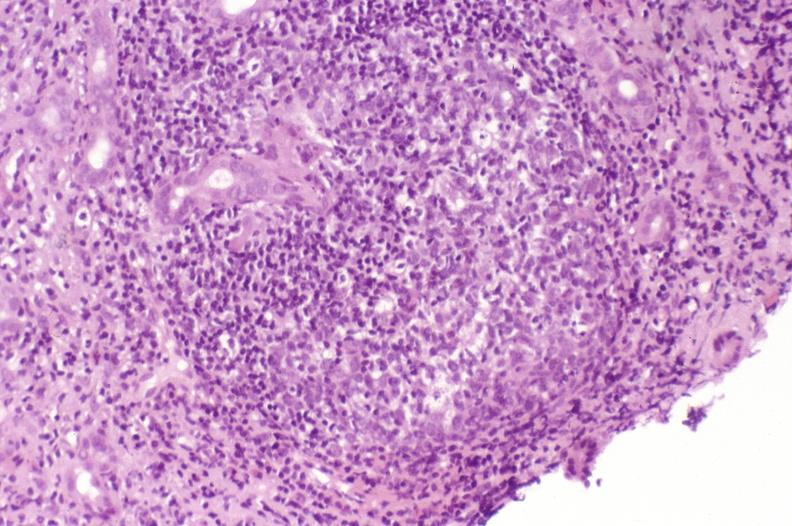what is present?
Answer the question using a single word or phrase. Hepatobiliary 